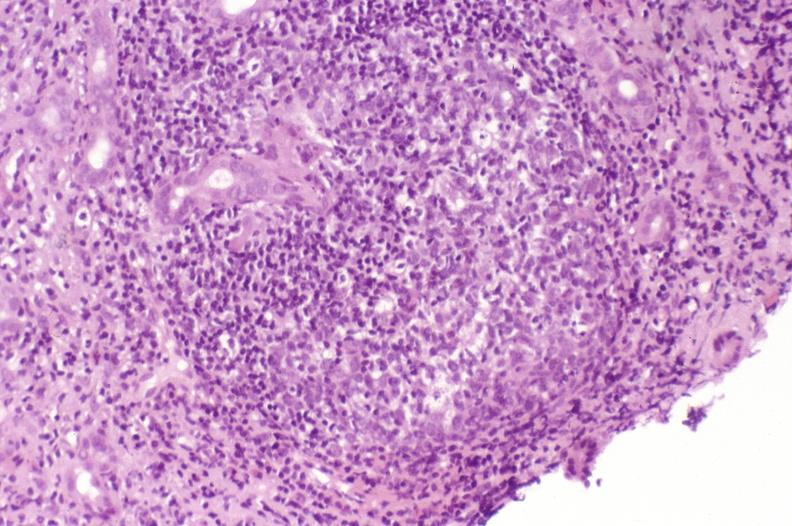what is present?
Answer the question using a single word or phrase. Hepatobiliary 